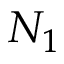Convert formula to latex. <formula><loc_0><loc_0><loc_500><loc_500>N _ { 1 }</formula> 